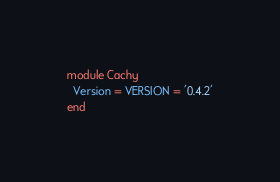<code> <loc_0><loc_0><loc_500><loc_500><_Ruby_>module Cachy
  Version = VERSION = '0.4.2'
end
</code> 